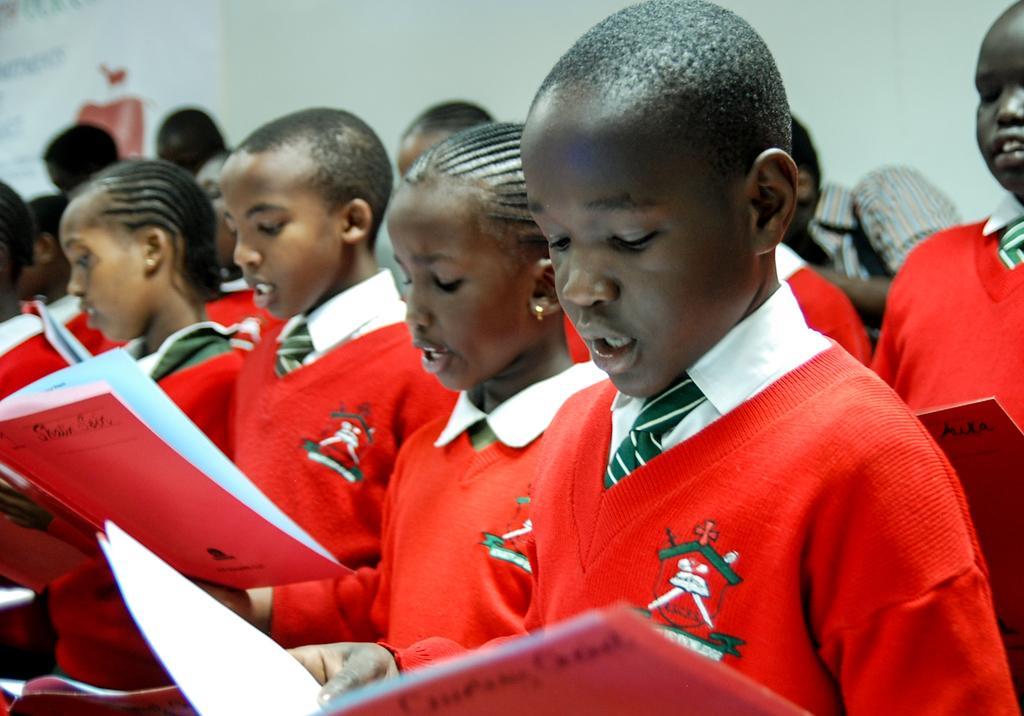Describe this image in one or two sentences. There are kids holding books. In the background we can see wall and poster. 